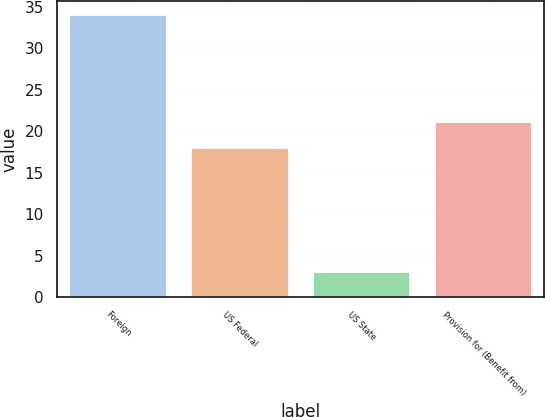<chart> <loc_0><loc_0><loc_500><loc_500><bar_chart><fcel>Foreign<fcel>US Federal<fcel>US State<fcel>Provision for (Benefit from)<nl><fcel>34<fcel>18<fcel>3<fcel>21.1<nl></chart> 